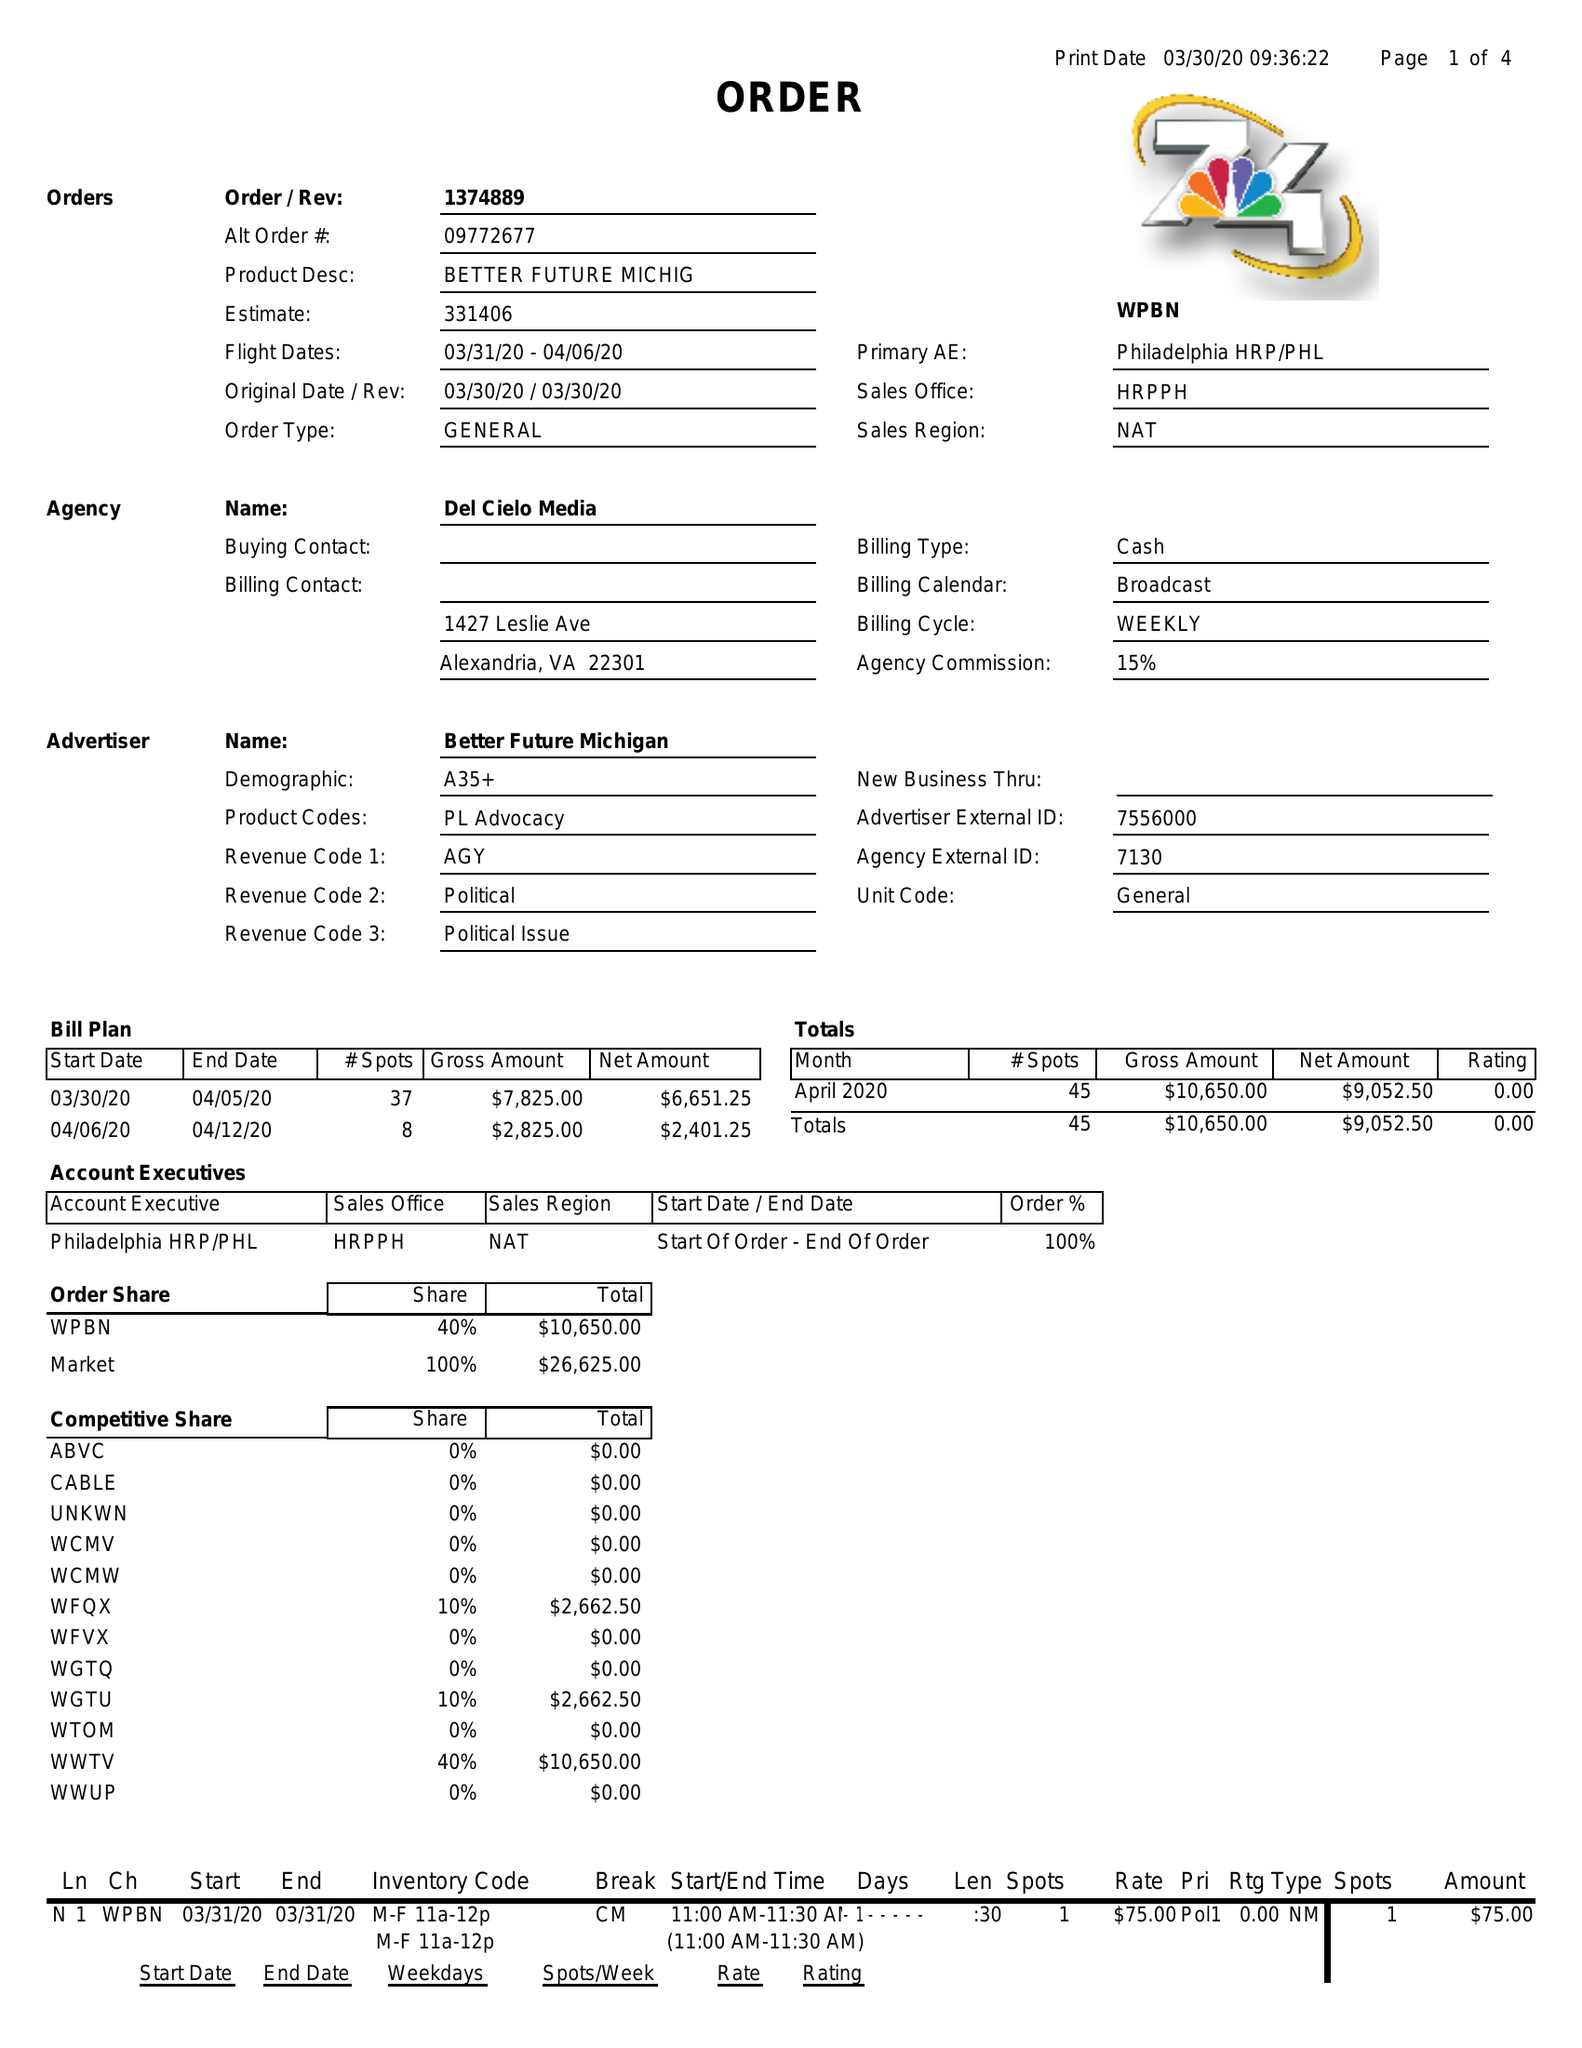What is the value for the flight_from?
Answer the question using a single word or phrase. 03/31/20 